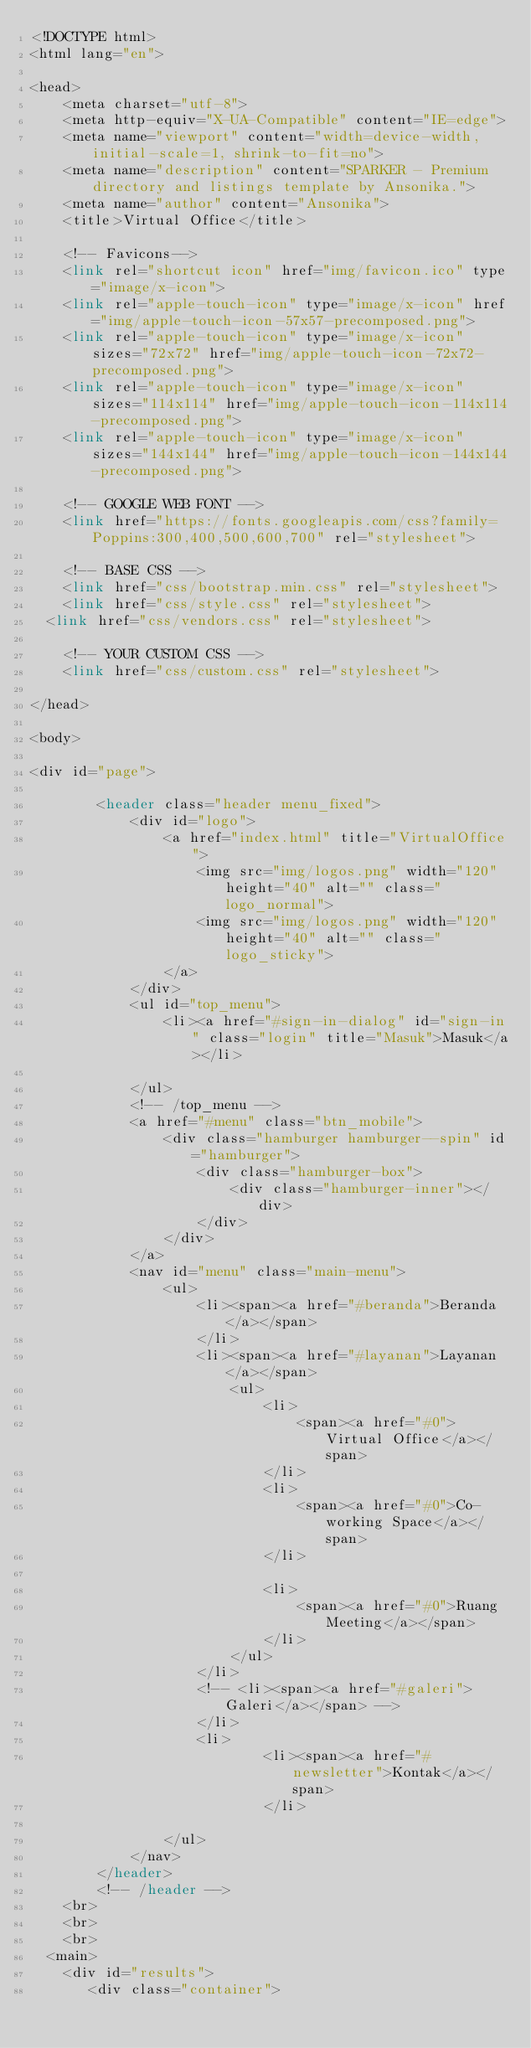Convert code to text. <code><loc_0><loc_0><loc_500><loc_500><_PHP_><!DOCTYPE html>
<html lang="en">

<head>
    <meta charset="utf-8">
    <meta http-equiv="X-UA-Compatible" content="IE=edge">
    <meta name="viewport" content="width=device-width, initial-scale=1, shrink-to-fit=no">
    <meta name="description" content="SPARKER - Premium directory and listings template by Ansonika.">
    <meta name="author" content="Ansonika">
    <title>Virtual Office</title>

    <!-- Favicons-->
    <link rel="shortcut icon" href="img/favicon.ico" type="image/x-icon">
    <link rel="apple-touch-icon" type="image/x-icon" href="img/apple-touch-icon-57x57-precomposed.png">
    <link rel="apple-touch-icon" type="image/x-icon" sizes="72x72" href="img/apple-touch-icon-72x72-precomposed.png">
    <link rel="apple-touch-icon" type="image/x-icon" sizes="114x114" href="img/apple-touch-icon-114x114-precomposed.png">
    <link rel="apple-touch-icon" type="image/x-icon" sizes="144x144" href="img/apple-touch-icon-144x144-precomposed.png">

    <!-- GOOGLE WEB FONT -->
    <link href="https://fonts.googleapis.com/css?family=Poppins:300,400,500,600,700" rel="stylesheet">

    <!-- BASE CSS -->
    <link href="css/bootstrap.min.css" rel="stylesheet">
    <link href="css/style.css" rel="stylesheet">
	<link href="css/vendors.css" rel="stylesheet">

    <!-- YOUR CUSTOM CSS -->
    <link href="css/custom.css" rel="stylesheet">

</head>

<body>
	
<div id="page">
		
        <header class="header menu_fixed">
            <div id="logo">
                <a href="index.html" title="VirtualOffice">
                    <img src="img/logos.png" width="120" height="40" alt="" class="logo_normal">
                    <img src="img/logos.png" width="120" height="40" alt="" class="logo_sticky">
                </a>
            </div>
            <ul id="top_menu">
                <li><a href="#sign-in-dialog" id="sign-in" class="login" title="Masuk">Masuk</a></li>
                
            </ul>
            <!-- /top_menu -->
            <a href="#menu" class="btn_mobile">
                <div class="hamburger hamburger--spin" id="hamburger">
                    <div class="hamburger-box">
                        <div class="hamburger-inner"></div>
                    </div>
                </div>
            </a>
            <nav id="menu" class="main-menu">
                <ul>
                    <li><span><a href="#beranda">Beranda</a></span>
                    </li>
                    <li><span><a href="#layanan">Layanan</a></span>
                        <ul>
                            <li>
                                <span><a href="#0">Virtual Office</a></span>
                            </li>
                            <li>
                                <span><a href="#0">Co-working Space</a></span>
                            </li>
                            
                            <li>
                                <span><a href="#0">Ruang Meeting</a></span>
                            </li>
                        </ul>
                    </li>
                    <!-- <li><span><a href="#galeri">Galeri</a></span> -->
                    </li>
                    <li>
                            <li><span><a href="#newsletter">Kontak</a></span>
                            </li>
                    
                </ul>
            </nav>
        </header>
        <!-- /header -->
    <br>
    <br>
    <br>
	<main>
		<div id="results">
		   <div class="container"></code> 